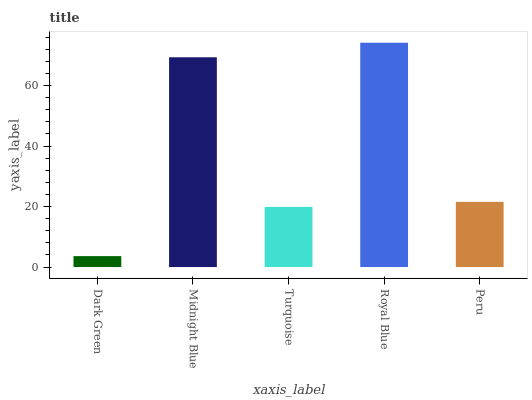Is Midnight Blue the minimum?
Answer yes or no. No. Is Midnight Blue the maximum?
Answer yes or no. No. Is Midnight Blue greater than Dark Green?
Answer yes or no. Yes. Is Dark Green less than Midnight Blue?
Answer yes or no. Yes. Is Dark Green greater than Midnight Blue?
Answer yes or no. No. Is Midnight Blue less than Dark Green?
Answer yes or no. No. Is Peru the high median?
Answer yes or no. Yes. Is Peru the low median?
Answer yes or no. Yes. Is Dark Green the high median?
Answer yes or no. No. Is Midnight Blue the low median?
Answer yes or no. No. 